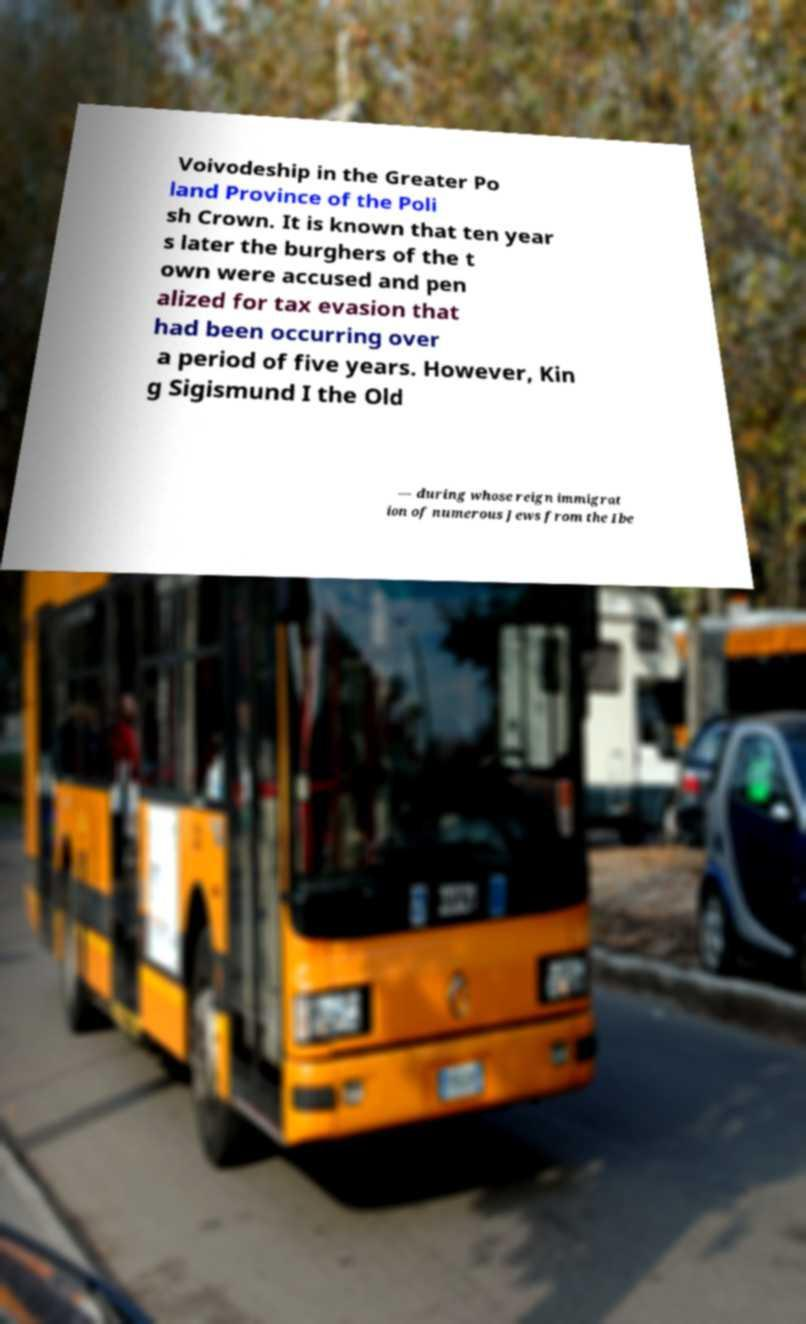Could you assist in decoding the text presented in this image and type it out clearly? Voivodeship in the Greater Po land Province of the Poli sh Crown. It is known that ten year s later the burghers of the t own were accused and pen alized for tax evasion that had been occurring over a period of five years. However, Kin g Sigismund I the Old — during whose reign immigrat ion of numerous Jews from the Ibe 